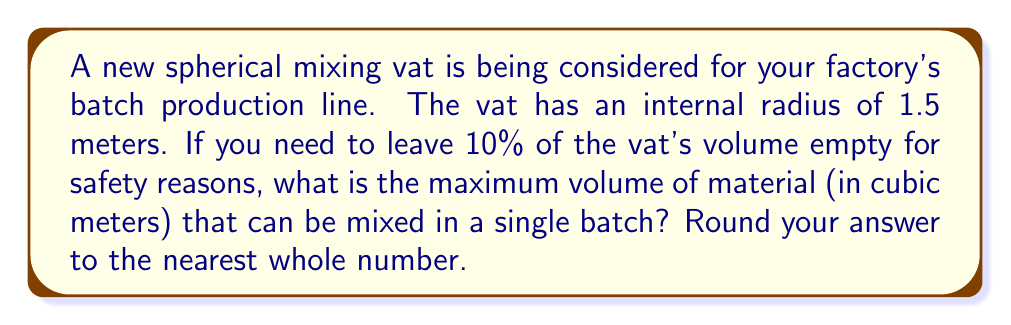Solve this math problem. To solve this problem, we'll follow these steps:

1) First, we need to calculate the total volume of the spherical vat. The formula for the volume of a sphere is:

   $$V = \frac{4}{3}\pi r^3$$

   Where $r$ is the radius of the sphere.

2) Plugging in our radius of 1.5 meters:

   $$V = \frac{4}{3}\pi (1.5)^3 = \frac{4}{3}\pi (3.375) \approx 14.137 \text{ m}^3$$

3) However, we need to leave 10% of this volume empty. So we can only use 90% of the total volume:

   $$\text{Usable Volume} = 90\% \text{ of Total Volume}$$
   $$\text{Usable Volume} = 0.90 \times 14.137 \approx 12.723 \text{ m}^3$$

4) Rounding to the nearest whole number:

   $$12.723 \text{ m}^3 \approx 13 \text{ m}^3$$

Therefore, the maximum volume of material that can be mixed in a single batch is approximately 13 cubic meters.
Answer: 13 m³ 